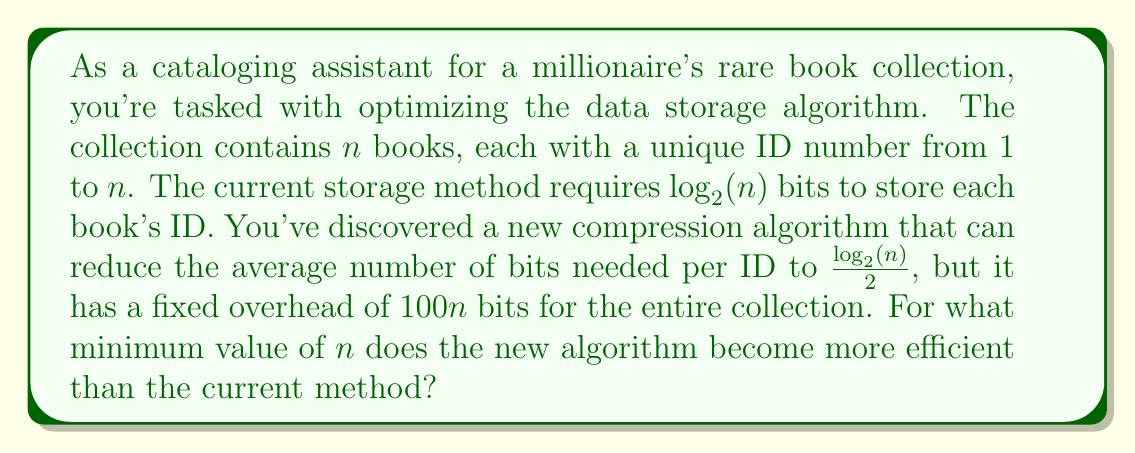Show me your answer to this math problem. Let's approach this step-by-step:

1) First, let's express the total number of bits required for each method:

   Current method: $n \cdot \log_2(n)$ bits
   New algorithm: $100n + n \cdot \frac{\log_2(n)}{2}$ bits

2) The new algorithm becomes more efficient when:

   $100n + n \cdot \frac{\log_2(n)}{2} < n \cdot \log_2(n)$

3) Let's simplify this inequality:

   $100 + \frac{\log_2(n)}{2} < \log_2(n)$

4) Further simplification:

   $100 < \frac{\log_2(n)}{2}$

5) Multiply both sides by 2:

   $200 < \log_2(n)$

6) Now, let's solve for $n$:

   $2^{200} < n$

7) $2^{200}$ is an enormously large number, approximately equal to $1.61 \times 10^{60}$.

8) Since $n$ must be an integer, we need to round up to the next whole number.

Therefore, the new algorithm becomes more efficient when $n \geq 1.61 \times 10^{60} + 1$.
Answer: The minimum value of $n$ for which the new algorithm becomes more efficient is $\lceil 2^{200} \rceil + 1 \approx 1.61 \times 10^{60} + 1$. 